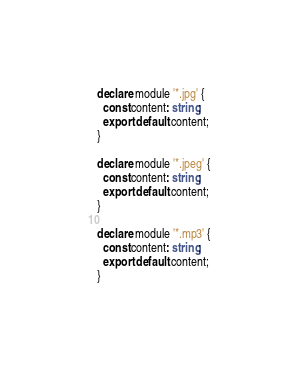<code> <loc_0><loc_0><loc_500><loc_500><_TypeScript_>declare module '*.jpg' {
  const content: string;
  export default content;
}

declare module '*.jpeg' {
  const content: string;
  export default content;
}

declare module '*.mp3' {
  const content: string;
  export default content;
}</code> 